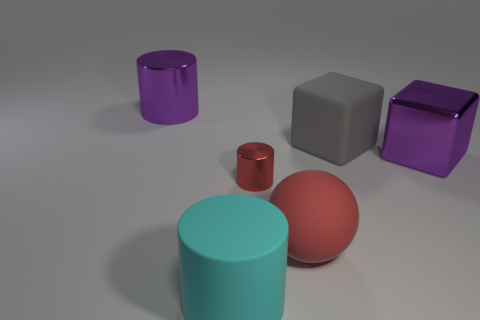Is the number of purple metal cylinders that are in front of the shiny block the same as the number of large purple things that are right of the red rubber object?
Provide a succinct answer. No. There is a object that is in front of the large red sphere; is it the same size as the purple metal object that is to the right of the small red object?
Make the answer very short. Yes. What number of other things are the same color as the tiny thing?
Provide a succinct answer. 1. There is another thing that is the same color as the small object; what is its material?
Provide a short and direct response. Rubber. Is the number of matte cylinders behind the tiny red cylinder greater than the number of big green matte balls?
Give a very brief answer. No. Do the large cyan matte thing and the big red object have the same shape?
Give a very brief answer. No. How many purple objects have the same material as the red cylinder?
Make the answer very short. 2. What size is the purple thing that is the same shape as the big gray object?
Your response must be concise. Large. Is the purple metallic cylinder the same size as the cyan rubber object?
Offer a terse response. Yes. There is a big metallic thing to the left of the large cylinder that is in front of the large metallic cylinder that is behind the large red rubber sphere; what is its shape?
Provide a succinct answer. Cylinder. 